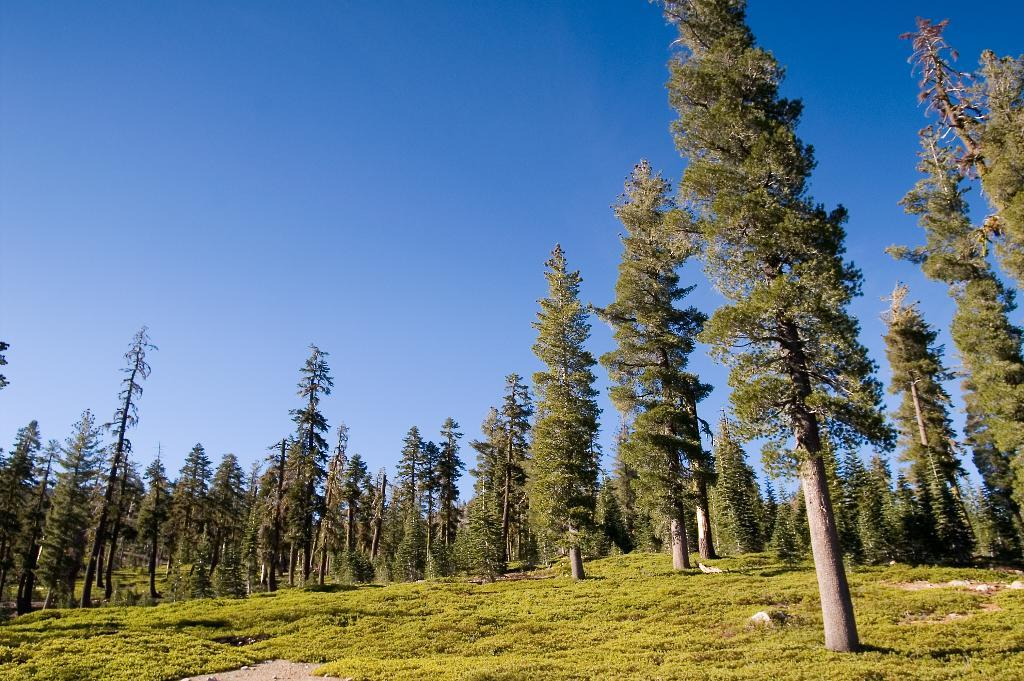What type of environment is shown in the image? The image depicts a forest. What are the main features of the forest? There are trees in the image. What can be seen above the trees in the image? The sky is visible at the top of the image. What type of vegetation is present at the bottom of the image? Grass is present at the bottom of the image. Where is the sugar mine located in the image? There is no sugar mine present in the image; it depicts a forest with trees, sky, and grass. Can you see any volcanic activity in the image? There is no volcanic activity present in the image; it depicts a forest with trees, sky, and grass. 